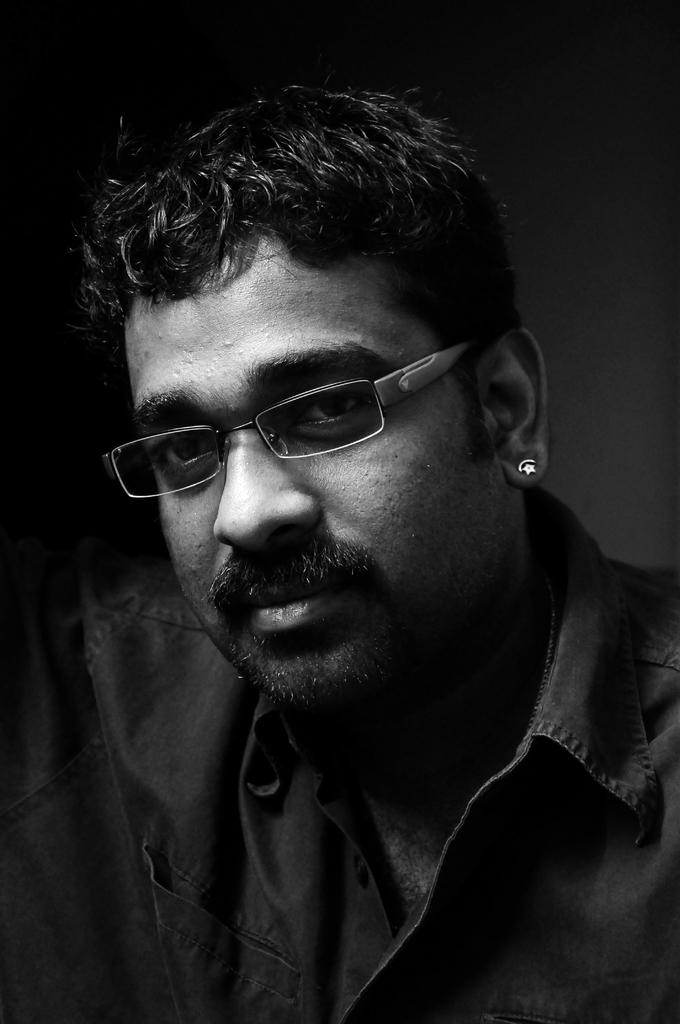Who is present in the image? There is a man in the image. What can be seen on the man's face? The man is wearing spectacles. Are there any accessories visible on the man? Yes, the man has a stud in his ear. What color is the background of the image? The background of the image is black. What type of dress is the man wearing in the image? There is no dress present in the image; the man is wearing spectacles and has a stud in his ear. 